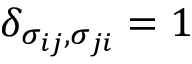Convert formula to latex. <formula><loc_0><loc_0><loc_500><loc_500>\delta _ { \sigma _ { i j } , \sigma _ { j i } } = 1</formula> 